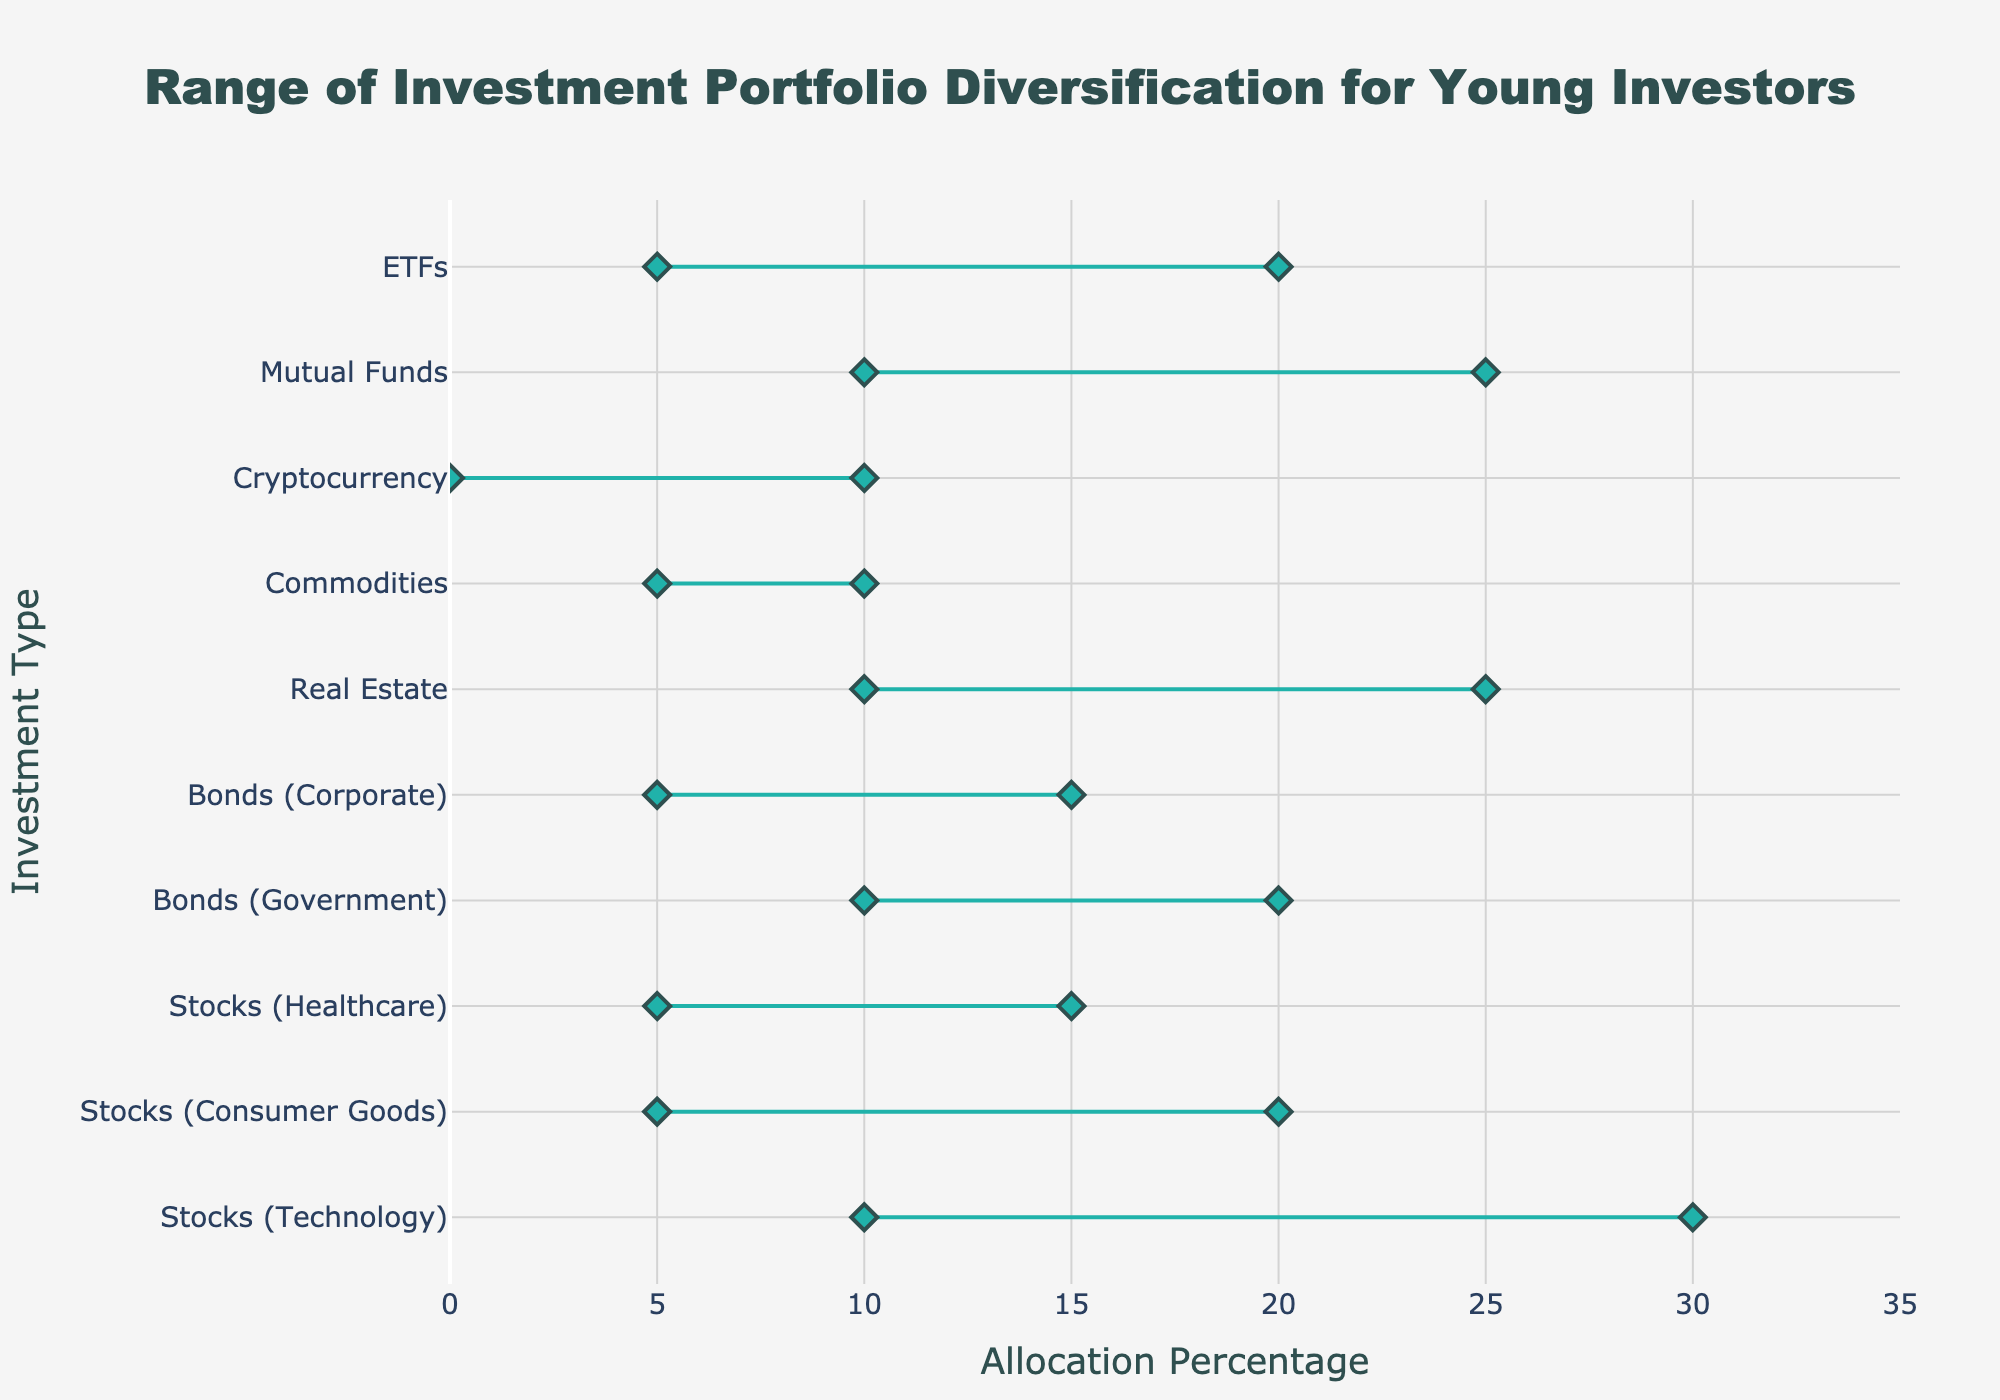What is the title of the figure? The title of the figure is located at the top center.
Answer: Range of Investment Portfolio Diversification for Young Investors What is the minimum allocation percentage for Cryptocurrency? The minimum allocation percentage for each investment type is displayed on the left marker of each line in the plot.
Answer: 0% What is the maximum allocation percentage for Real Estate? The maximum allocation percentage for each investment type is displayed on the right marker of each line in the plot.
Answer: 25% Which investment type has the smallest maximum allocation percentage? To find the investment type with the smallest maximum allocation percentage, look for the lowest value on the rightmost end of the horizontal lines.
Answer: Commodities (10%) What is the range of allocation for Stocks (Consumer Goods)? The range is calculated by subtracting the minimum allocation percentage from the maximum allocation percentage for Stocks (Consumer Goods).
Answer: 15% How many investment types have a minimum allocation percentage of 10% or higher? Count the number of horizontal lines that start at or above the 10% mark on the x-axis.
Answer: 4 Which investment type has the largest range of allocation percentages? Determine the range for each investment type by subtracting the minimum allocation percentage from the maximum allocation percentage and identify the largest.
Answer: Stocks (Technology) What is the average of the maximum allocation percentages for Stocks (Technology), Bonds (Government), and ETFs? Add the maximum allocation percentages for these three types and divide by the number of types: (30 + 20 + 20) / 3.
Answer: 23.33% Which investment types have both their minimum and maximum allocation percentages below 20%? Look for horizontal lines where both markers (minimum and maximum) are under the 20% mark.
Answer: Stocks (Consumer Goods), Stocks (Healthcare), Bonds (Corporate), Commodities, Cryptocurrency, ETFs If you want to diversify equally between Stocks (Technology) and Real Estate, what is the range of total allocation percentages you would consider? Add the minimum and maximum allocation percentages for Stocks (Technology) and Real Estate: Min: 10+10=20, Max: 30+25=55.
Answer: From 20% to 55% 